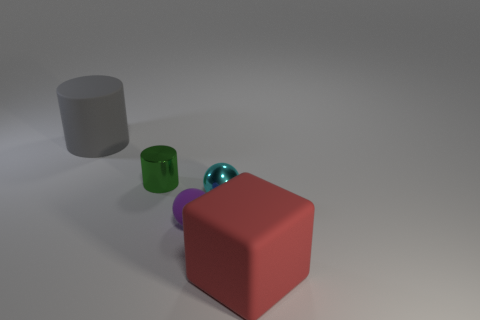There is another object that is the same shape as the big gray rubber object; what color is it?
Keep it short and to the point. Green. What shape is the red thing?
Ensure brevity in your answer.  Cube. What number of objects are either small yellow objects or balls?
Provide a succinct answer. 2. Is the color of the cylinder that is on the right side of the big gray thing the same as the big matte object that is in front of the gray rubber thing?
Ensure brevity in your answer.  No. What number of other things are there of the same shape as the large red matte object?
Provide a succinct answer. 0. Are there any tiny yellow objects?
Offer a terse response. No. How many objects are cyan cylinders or rubber things on the left side of the rubber cube?
Your answer should be very brief. 2. There is a thing left of the green metallic object; does it have the same size as the rubber sphere?
Make the answer very short. No. What number of other things are there of the same size as the green thing?
Your response must be concise. 2. The rubber block is what color?
Provide a succinct answer. Red. 